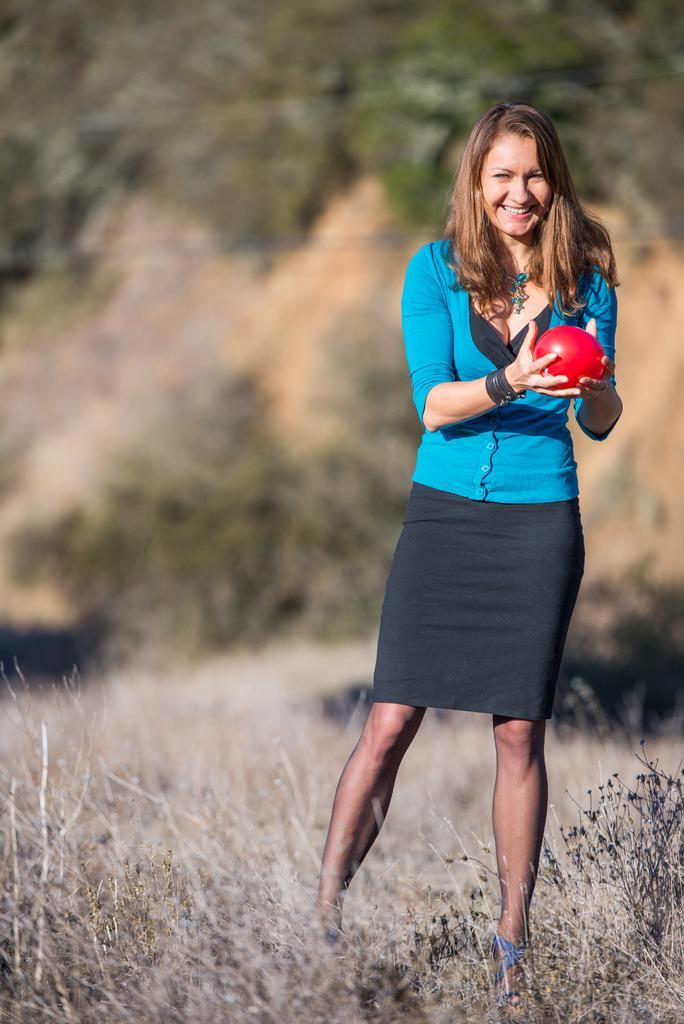Please provide a concise description of this image. On the right there is a woman who is wearing the blue top, black dress and sandal. She is holding red balloon. At the bottom we can see grass. In the background we can see many trees. 